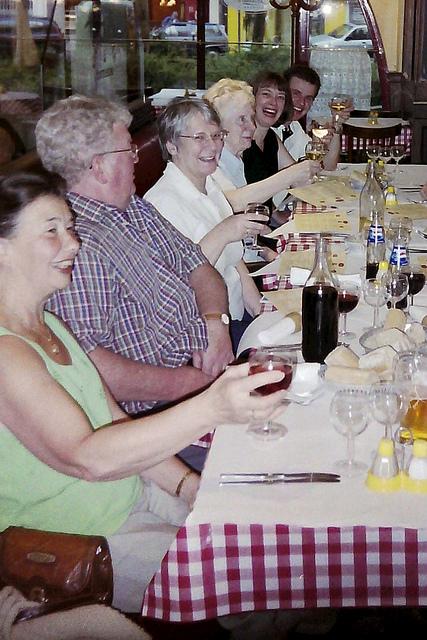Which room is this?
Write a very short answer. Dining room. Do you think that the average age of the people in that photo is over 50?
Give a very brief answer. Yes. Are some people drinking wine?
Short answer required. Yes. 